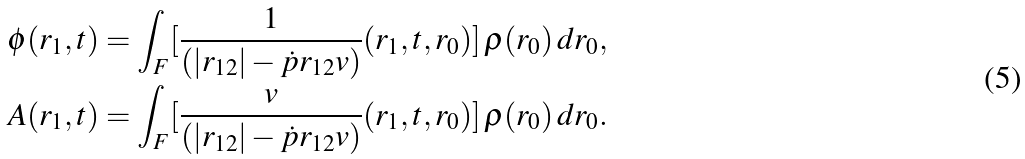Convert formula to latex. <formula><loc_0><loc_0><loc_500><loc_500>\phi ( r _ { 1 } , t ) & = \int _ { F } [ \frac { 1 } { ( | r _ { 1 2 } | - \dot { p } { r _ { 1 2 } } { v } ) } ( r _ { 1 } , t , r _ { 0 } ) ] \, \varrho ( r _ { 0 } ) \, d r _ { 0 } , \\ A ( r _ { 1 } , t ) & = \int _ { F } [ \frac { v } { ( | r _ { 1 2 } | - \dot { p } { r _ { 1 2 } } { v } ) } ( r _ { 1 } , t , r _ { 0 } ) ] \, \varrho ( r _ { 0 } ) \, d r _ { 0 } . \\</formula> 